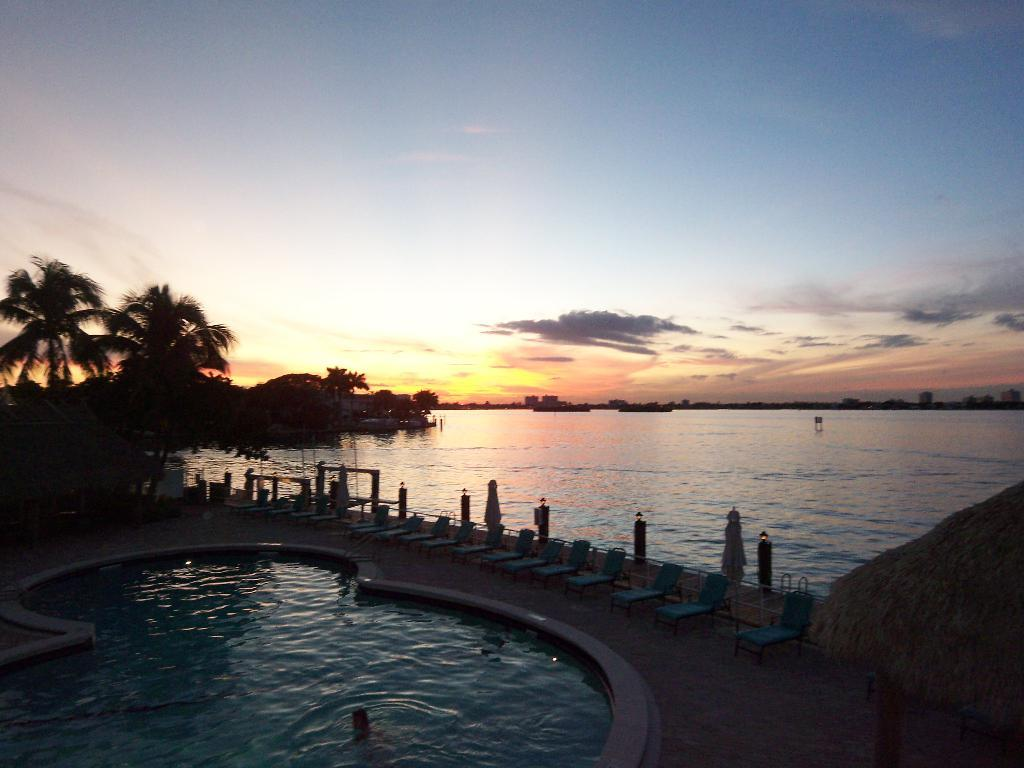What is the main feature of the image? There is a pool with water in the image. Who or what is in the pool? There is a person in the pool. What can be seen near the pool? There is a path in the image, and chairs are on the path. What is visible in the background of the image? There are trees, water, and the sky visible in the background of the image. What type of gun is being used to surprise the person in the pool? There is no gun or surprise element present in the image; it only features a pool, a person, a path, chairs, trees, water, and the sky in the background. 